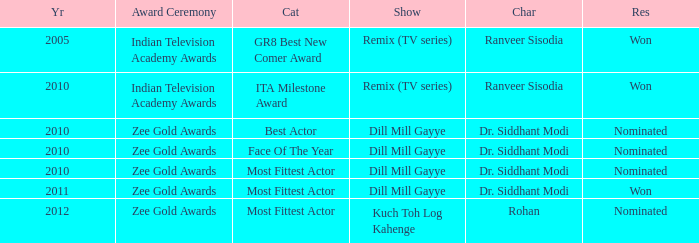Which character was nominated in the 2010 Indian Television Academy Awards? Ranveer Sisodia. Parse the table in full. {'header': ['Yr', 'Award Ceremony', 'Cat', 'Show', 'Char', 'Res'], 'rows': [['2005', 'Indian Television Academy Awards', 'GR8 Best New Comer Award', 'Remix (TV series)', 'Ranveer Sisodia', 'Won'], ['2010', 'Indian Television Academy Awards', 'ITA Milestone Award', 'Remix (TV series)', 'Ranveer Sisodia', 'Won'], ['2010', 'Zee Gold Awards', 'Best Actor', 'Dill Mill Gayye', 'Dr. Siddhant Modi', 'Nominated'], ['2010', 'Zee Gold Awards', 'Face Of The Year', 'Dill Mill Gayye', 'Dr. Siddhant Modi', 'Nominated'], ['2010', 'Zee Gold Awards', 'Most Fittest Actor', 'Dill Mill Gayye', 'Dr. Siddhant Modi', 'Nominated'], ['2011', 'Zee Gold Awards', 'Most Fittest Actor', 'Dill Mill Gayye', 'Dr. Siddhant Modi', 'Won'], ['2012', 'Zee Gold Awards', 'Most Fittest Actor', 'Kuch Toh Log Kahenge', 'Rohan', 'Nominated']]} 